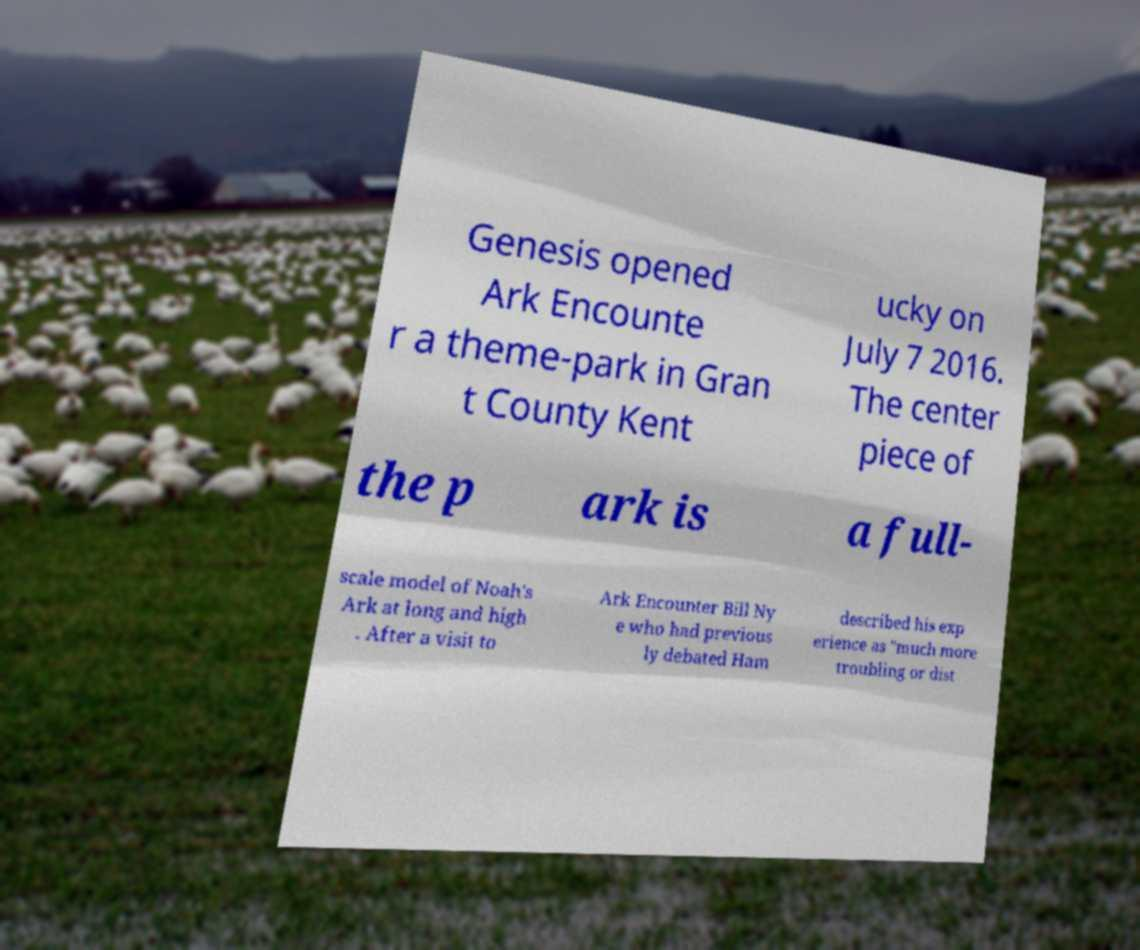Please identify and transcribe the text found in this image. Genesis opened Ark Encounte r a theme-park in Gran t County Kent ucky on July 7 2016. The center piece of the p ark is a full- scale model of Noah's Ark at long and high . After a visit to Ark Encounter Bill Ny e who had previous ly debated Ham described his exp erience as "much more troubling or dist 